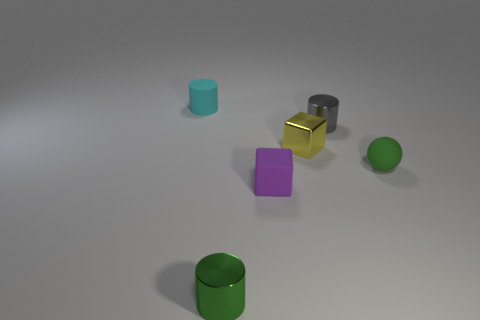Add 3 small cyan objects. How many objects exist? 9 Subtract all balls. How many objects are left? 5 Add 6 shiny objects. How many shiny objects exist? 9 Subtract 1 purple blocks. How many objects are left? 5 Subtract all purple objects. Subtract all tiny metal cubes. How many objects are left? 4 Add 4 tiny matte blocks. How many tiny matte blocks are left? 5 